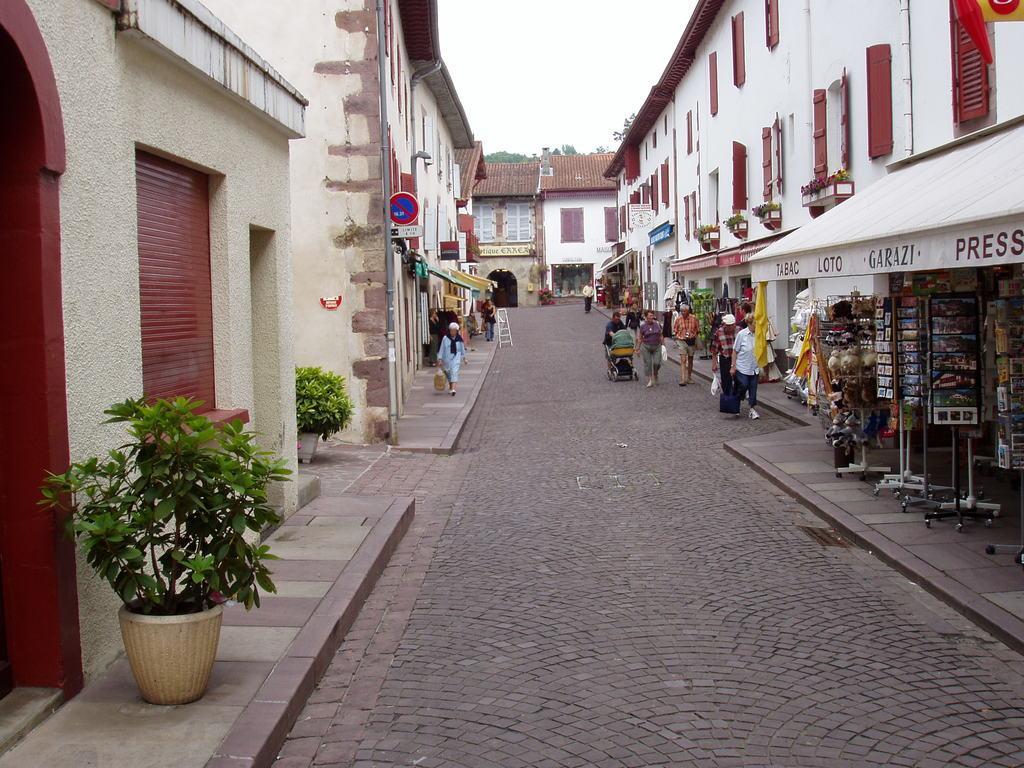How would you summarize this image in a sentence or two? In this image we can see road. To the both sides of the boat buildings and shops are there. People are moving on the road and pavement. Left side of the image plant pots are present. 